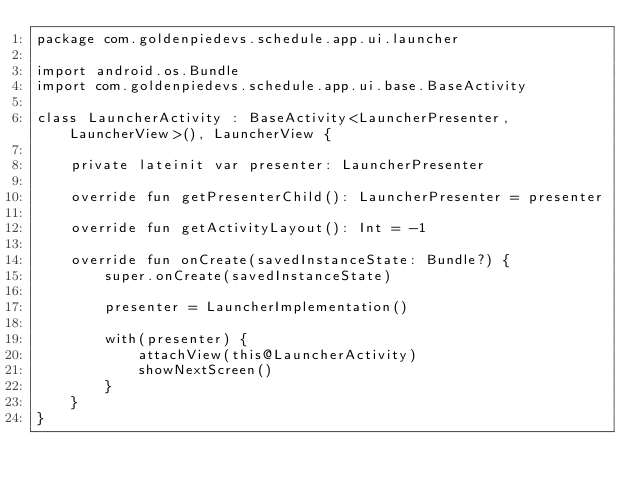<code> <loc_0><loc_0><loc_500><loc_500><_Kotlin_>package com.goldenpiedevs.schedule.app.ui.launcher

import android.os.Bundle
import com.goldenpiedevs.schedule.app.ui.base.BaseActivity

class LauncherActivity : BaseActivity<LauncherPresenter, LauncherView>(), LauncherView {

    private lateinit var presenter: LauncherPresenter

    override fun getPresenterChild(): LauncherPresenter = presenter

    override fun getActivityLayout(): Int = -1

    override fun onCreate(savedInstanceState: Bundle?) {
        super.onCreate(savedInstanceState)

        presenter = LauncherImplementation()

        with(presenter) {
            attachView(this@LauncherActivity)
            showNextScreen()
        }
    }
}</code> 